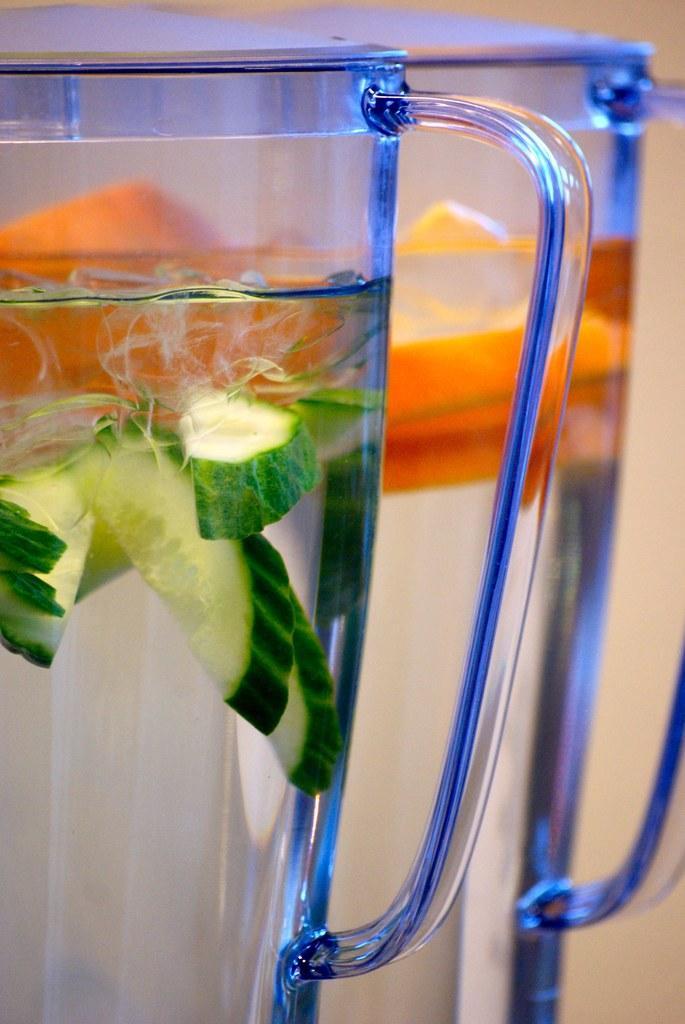How would you summarize this image in a sentence or two? In this image we can see some glasses containing the water and some pieces of cucumber inside it. 